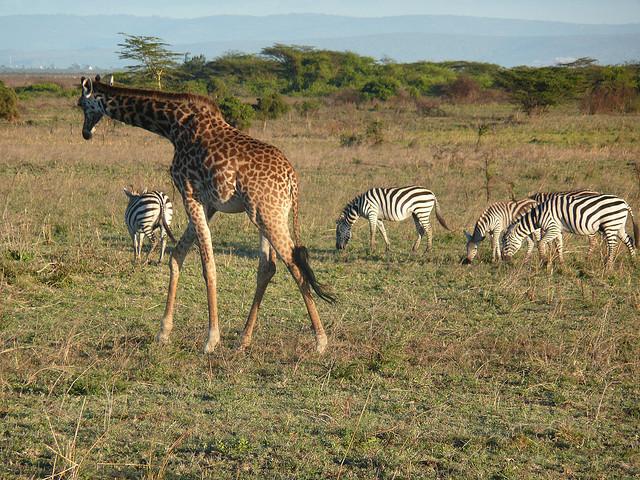Which of these animals typically eats vegetation form trees?
Write a very short answer. Giraffe. Is this a baby giraffe?
Be succinct. No. Do the giraffe and zebra get along?
Give a very brief answer. Yes. 